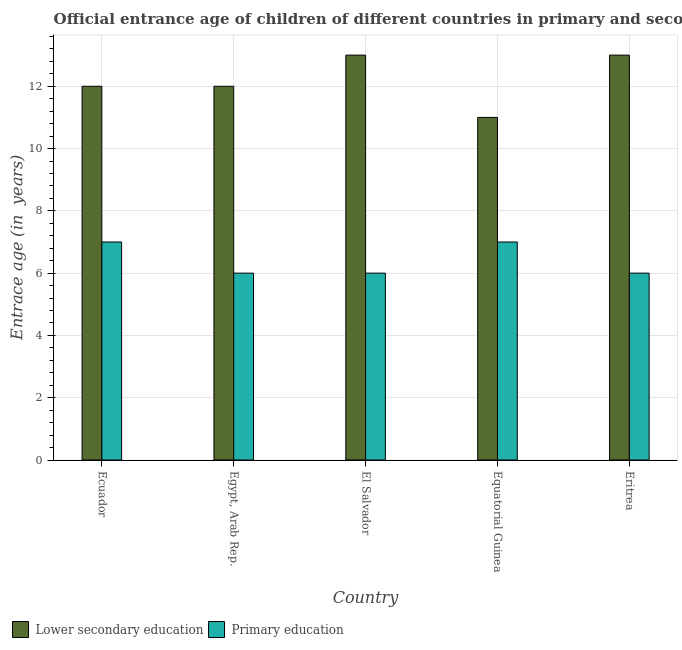Are the number of bars on each tick of the X-axis equal?
Offer a terse response. Yes. What is the label of the 5th group of bars from the left?
Make the answer very short. Eritrea. In how many cases, is the number of bars for a given country not equal to the number of legend labels?
Provide a succinct answer. 0. What is the entrance age of chiildren in primary education in El Salvador?
Offer a terse response. 6. Across all countries, what is the maximum entrance age of chiildren in primary education?
Give a very brief answer. 7. Across all countries, what is the minimum entrance age of chiildren in primary education?
Give a very brief answer. 6. In which country was the entrance age of chiildren in primary education maximum?
Provide a succinct answer. Ecuador. In which country was the entrance age of chiildren in primary education minimum?
Provide a short and direct response. Egypt, Arab Rep. What is the total entrance age of children in lower secondary education in the graph?
Keep it short and to the point. 61. What is the difference between the entrance age of chiildren in primary education in Ecuador and that in El Salvador?
Your response must be concise. 1. What is the difference between the entrance age of chiildren in primary education in El Salvador and the entrance age of children in lower secondary education in Egypt, Arab Rep.?
Offer a terse response. -6. What is the difference between the entrance age of children in lower secondary education and entrance age of chiildren in primary education in Equatorial Guinea?
Your response must be concise. 4. In how many countries, is the entrance age of children in lower secondary education greater than 3.2 years?
Give a very brief answer. 5. What is the difference between the highest and the second highest entrance age of chiildren in primary education?
Provide a short and direct response. 0. What is the difference between the highest and the lowest entrance age of children in lower secondary education?
Offer a very short reply. 2. In how many countries, is the entrance age of children in lower secondary education greater than the average entrance age of children in lower secondary education taken over all countries?
Offer a very short reply. 2. Is the sum of the entrance age of children in lower secondary education in Ecuador and El Salvador greater than the maximum entrance age of chiildren in primary education across all countries?
Your answer should be compact. Yes. What does the 2nd bar from the left in El Salvador represents?
Ensure brevity in your answer.  Primary education. Are all the bars in the graph horizontal?
Give a very brief answer. No. How many countries are there in the graph?
Offer a very short reply. 5. What is the difference between two consecutive major ticks on the Y-axis?
Your answer should be very brief. 2. Are the values on the major ticks of Y-axis written in scientific E-notation?
Give a very brief answer. No. Does the graph contain any zero values?
Keep it short and to the point. No. Does the graph contain grids?
Your response must be concise. Yes. How many legend labels are there?
Provide a succinct answer. 2. What is the title of the graph?
Give a very brief answer. Official entrance age of children of different countries in primary and secondary education. What is the label or title of the X-axis?
Keep it short and to the point. Country. What is the label or title of the Y-axis?
Keep it short and to the point. Entrace age (in  years). What is the Entrace age (in  years) in Lower secondary education in Ecuador?
Make the answer very short. 12. What is the Entrace age (in  years) of Primary education in Ecuador?
Your answer should be compact. 7. What is the Entrace age (in  years) of Primary education in Egypt, Arab Rep.?
Provide a succinct answer. 6. What is the Entrace age (in  years) in Primary education in El Salvador?
Ensure brevity in your answer.  6. Across all countries, what is the maximum Entrace age (in  years) in Lower secondary education?
Your response must be concise. 13. Across all countries, what is the minimum Entrace age (in  years) in Lower secondary education?
Keep it short and to the point. 11. What is the total Entrace age (in  years) in Lower secondary education in the graph?
Ensure brevity in your answer.  61. What is the difference between the Entrace age (in  years) in Primary education in Ecuador and that in Egypt, Arab Rep.?
Ensure brevity in your answer.  1. What is the difference between the Entrace age (in  years) of Lower secondary education in Ecuador and that in El Salvador?
Your answer should be very brief. -1. What is the difference between the Entrace age (in  years) of Lower secondary education in Ecuador and that in Eritrea?
Make the answer very short. -1. What is the difference between the Entrace age (in  years) in Lower secondary education in Egypt, Arab Rep. and that in El Salvador?
Ensure brevity in your answer.  -1. What is the difference between the Entrace age (in  years) in Lower secondary education in Egypt, Arab Rep. and that in Equatorial Guinea?
Provide a short and direct response. 1. What is the difference between the Entrace age (in  years) of Primary education in Egypt, Arab Rep. and that in Equatorial Guinea?
Offer a terse response. -1. What is the difference between the Entrace age (in  years) of Lower secondary education in Egypt, Arab Rep. and that in Eritrea?
Make the answer very short. -1. What is the difference between the Entrace age (in  years) of Lower secondary education in El Salvador and that in Equatorial Guinea?
Keep it short and to the point. 2. What is the difference between the Entrace age (in  years) in Lower secondary education in Egypt, Arab Rep. and the Entrace age (in  years) in Primary education in Eritrea?
Provide a succinct answer. 6. What is the difference between the Entrace age (in  years) in Lower secondary education in El Salvador and the Entrace age (in  years) in Primary education in Equatorial Guinea?
Provide a short and direct response. 6. What is the average Entrace age (in  years) in Primary education per country?
Offer a very short reply. 6.4. What is the difference between the Entrace age (in  years) of Lower secondary education and Entrace age (in  years) of Primary education in Egypt, Arab Rep.?
Ensure brevity in your answer.  6. What is the difference between the Entrace age (in  years) of Lower secondary education and Entrace age (in  years) of Primary education in El Salvador?
Your answer should be very brief. 7. What is the difference between the Entrace age (in  years) of Lower secondary education and Entrace age (in  years) of Primary education in Eritrea?
Give a very brief answer. 7. What is the ratio of the Entrace age (in  years) of Lower secondary education in Ecuador to that in Egypt, Arab Rep.?
Your answer should be compact. 1. What is the ratio of the Entrace age (in  years) of Primary education in Ecuador to that in Egypt, Arab Rep.?
Provide a succinct answer. 1.17. What is the ratio of the Entrace age (in  years) in Lower secondary education in Ecuador to that in El Salvador?
Make the answer very short. 0.92. What is the ratio of the Entrace age (in  years) of Lower secondary education in Ecuador to that in Equatorial Guinea?
Give a very brief answer. 1.09. What is the ratio of the Entrace age (in  years) of Lower secondary education in Egypt, Arab Rep. to that in El Salvador?
Your answer should be very brief. 0.92. What is the ratio of the Entrace age (in  years) of Primary education in Egypt, Arab Rep. to that in El Salvador?
Provide a short and direct response. 1. What is the ratio of the Entrace age (in  years) of Lower secondary education in Egypt, Arab Rep. to that in Equatorial Guinea?
Ensure brevity in your answer.  1.09. What is the ratio of the Entrace age (in  years) of Primary education in Egypt, Arab Rep. to that in Equatorial Guinea?
Provide a short and direct response. 0.86. What is the ratio of the Entrace age (in  years) in Lower secondary education in El Salvador to that in Equatorial Guinea?
Your response must be concise. 1.18. What is the ratio of the Entrace age (in  years) of Primary education in El Salvador to that in Equatorial Guinea?
Offer a terse response. 0.86. What is the ratio of the Entrace age (in  years) of Lower secondary education in El Salvador to that in Eritrea?
Keep it short and to the point. 1. What is the ratio of the Entrace age (in  years) in Primary education in El Salvador to that in Eritrea?
Offer a terse response. 1. What is the ratio of the Entrace age (in  years) of Lower secondary education in Equatorial Guinea to that in Eritrea?
Offer a terse response. 0.85. What is the difference between the highest and the lowest Entrace age (in  years) of Lower secondary education?
Make the answer very short. 2. 